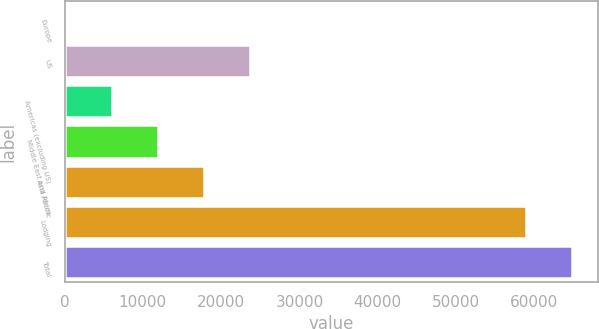Convert chart. <chart><loc_0><loc_0><loc_500><loc_500><bar_chart><fcel>Europe<fcel>US<fcel>Americas (excluding US)<fcel>Middle East and Africa<fcel>Asia Pacific<fcel>Lodging<fcel>Total<nl><fcel>191<fcel>23696.2<fcel>6067.3<fcel>11943.6<fcel>17819.9<fcel>58954<fcel>64830.3<nl></chart> 